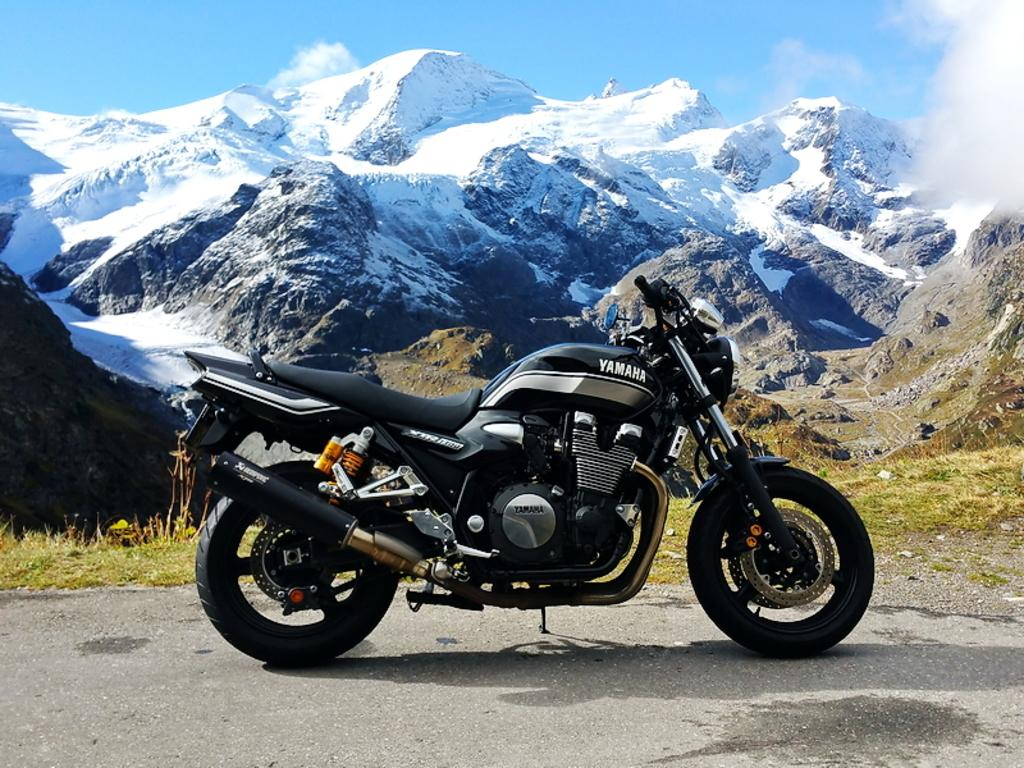What is on the road in the image? There is a bike on the road. What can be seen in the background of the image? There is grass and hills covered with snow in the background. What is visible in the sky in the image? The sky is visible with clouds in the image. Can you see a monkey jumping on the bike in the image? No, there is no monkey present in the image. What type of stamp is on the bike's tire in the image? There is no stamp on the bike's tire in the image. 